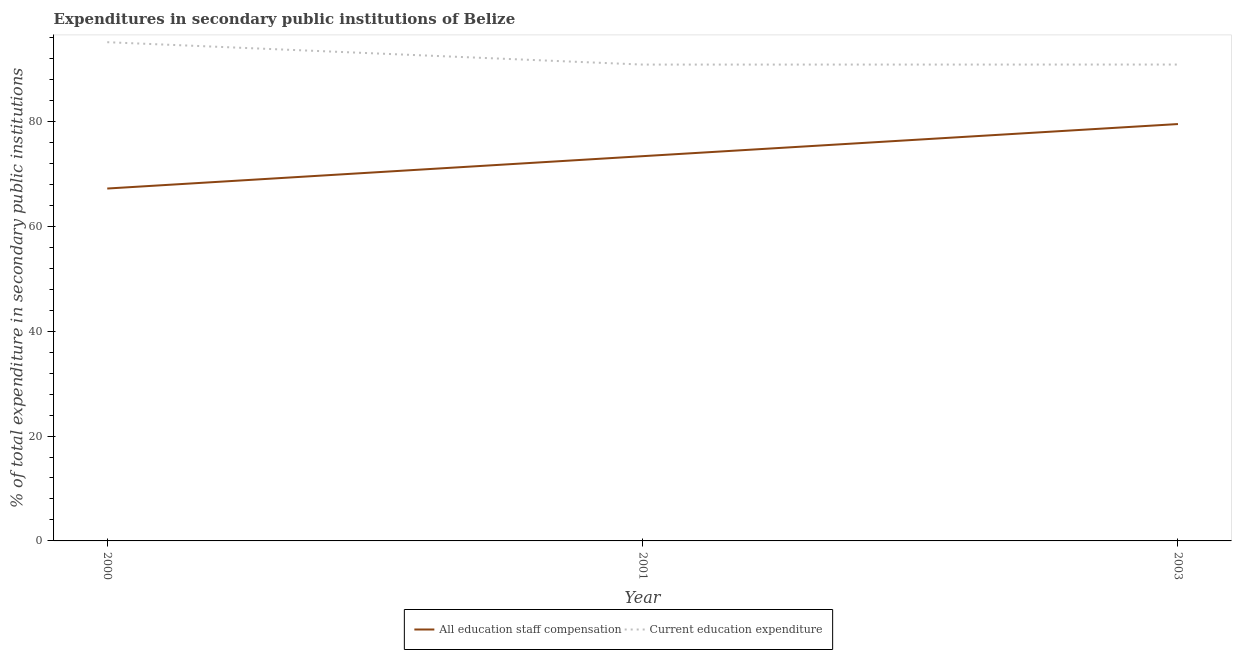Does the line corresponding to expenditure in education intersect with the line corresponding to expenditure in staff compensation?
Offer a very short reply. No. What is the expenditure in staff compensation in 2000?
Your answer should be very brief. 67.2. Across all years, what is the maximum expenditure in staff compensation?
Offer a very short reply. 79.49. Across all years, what is the minimum expenditure in staff compensation?
Ensure brevity in your answer.  67.2. In which year was the expenditure in education maximum?
Offer a terse response. 2000. What is the total expenditure in staff compensation in the graph?
Ensure brevity in your answer.  220.06. What is the difference between the expenditure in education in 2001 and that in 2003?
Your answer should be very brief. -0.01. What is the difference between the expenditure in staff compensation in 2000 and the expenditure in education in 2001?
Provide a short and direct response. -23.64. What is the average expenditure in education per year?
Give a very brief answer. 92.26. In the year 2001, what is the difference between the expenditure in education and expenditure in staff compensation?
Provide a succinct answer. 17.47. In how many years, is the expenditure in staff compensation greater than 40 %?
Your answer should be very brief. 3. What is the ratio of the expenditure in staff compensation in 2000 to that in 2003?
Offer a terse response. 0.85. Is the expenditure in staff compensation in 2000 less than that in 2003?
Your response must be concise. Yes. Is the difference between the expenditure in staff compensation in 2000 and 2003 greater than the difference between the expenditure in education in 2000 and 2003?
Give a very brief answer. No. What is the difference between the highest and the second highest expenditure in staff compensation?
Ensure brevity in your answer.  6.13. What is the difference between the highest and the lowest expenditure in staff compensation?
Provide a short and direct response. 12.3. Is the sum of the expenditure in education in 2000 and 2003 greater than the maximum expenditure in staff compensation across all years?
Your answer should be compact. Yes. Does the expenditure in education monotonically increase over the years?
Your answer should be compact. No. How many lines are there?
Provide a succinct answer. 2. Does the graph contain grids?
Keep it short and to the point. No. How are the legend labels stacked?
Your response must be concise. Horizontal. What is the title of the graph?
Keep it short and to the point. Expenditures in secondary public institutions of Belize. What is the label or title of the Y-axis?
Provide a succinct answer. % of total expenditure in secondary public institutions. What is the % of total expenditure in secondary public institutions in All education staff compensation in 2000?
Give a very brief answer. 67.2. What is the % of total expenditure in secondary public institutions of Current education expenditure in 2000?
Your response must be concise. 95.1. What is the % of total expenditure in secondary public institutions in All education staff compensation in 2001?
Provide a succinct answer. 73.37. What is the % of total expenditure in secondary public institutions in Current education expenditure in 2001?
Make the answer very short. 90.84. What is the % of total expenditure in secondary public institutions in All education staff compensation in 2003?
Your answer should be compact. 79.49. What is the % of total expenditure in secondary public institutions of Current education expenditure in 2003?
Your answer should be compact. 90.84. Across all years, what is the maximum % of total expenditure in secondary public institutions in All education staff compensation?
Your response must be concise. 79.49. Across all years, what is the maximum % of total expenditure in secondary public institutions of Current education expenditure?
Your response must be concise. 95.1. Across all years, what is the minimum % of total expenditure in secondary public institutions in All education staff compensation?
Your answer should be very brief. 67.2. Across all years, what is the minimum % of total expenditure in secondary public institutions in Current education expenditure?
Give a very brief answer. 90.84. What is the total % of total expenditure in secondary public institutions of All education staff compensation in the graph?
Offer a very short reply. 220.06. What is the total % of total expenditure in secondary public institutions in Current education expenditure in the graph?
Offer a terse response. 276.78. What is the difference between the % of total expenditure in secondary public institutions of All education staff compensation in 2000 and that in 2001?
Keep it short and to the point. -6.17. What is the difference between the % of total expenditure in secondary public institutions in Current education expenditure in 2000 and that in 2001?
Your answer should be compact. 4.27. What is the difference between the % of total expenditure in secondary public institutions in All education staff compensation in 2000 and that in 2003?
Your response must be concise. -12.3. What is the difference between the % of total expenditure in secondary public institutions in Current education expenditure in 2000 and that in 2003?
Your response must be concise. 4.26. What is the difference between the % of total expenditure in secondary public institutions in All education staff compensation in 2001 and that in 2003?
Make the answer very short. -6.13. What is the difference between the % of total expenditure in secondary public institutions in Current education expenditure in 2001 and that in 2003?
Your answer should be compact. -0.01. What is the difference between the % of total expenditure in secondary public institutions of All education staff compensation in 2000 and the % of total expenditure in secondary public institutions of Current education expenditure in 2001?
Your response must be concise. -23.64. What is the difference between the % of total expenditure in secondary public institutions in All education staff compensation in 2000 and the % of total expenditure in secondary public institutions in Current education expenditure in 2003?
Keep it short and to the point. -23.64. What is the difference between the % of total expenditure in secondary public institutions of All education staff compensation in 2001 and the % of total expenditure in secondary public institutions of Current education expenditure in 2003?
Ensure brevity in your answer.  -17.47. What is the average % of total expenditure in secondary public institutions of All education staff compensation per year?
Make the answer very short. 73.35. What is the average % of total expenditure in secondary public institutions in Current education expenditure per year?
Your response must be concise. 92.26. In the year 2000, what is the difference between the % of total expenditure in secondary public institutions of All education staff compensation and % of total expenditure in secondary public institutions of Current education expenditure?
Your answer should be compact. -27.91. In the year 2001, what is the difference between the % of total expenditure in secondary public institutions of All education staff compensation and % of total expenditure in secondary public institutions of Current education expenditure?
Make the answer very short. -17.47. In the year 2003, what is the difference between the % of total expenditure in secondary public institutions of All education staff compensation and % of total expenditure in secondary public institutions of Current education expenditure?
Make the answer very short. -11.35. What is the ratio of the % of total expenditure in secondary public institutions of All education staff compensation in 2000 to that in 2001?
Make the answer very short. 0.92. What is the ratio of the % of total expenditure in secondary public institutions of Current education expenditure in 2000 to that in 2001?
Give a very brief answer. 1.05. What is the ratio of the % of total expenditure in secondary public institutions of All education staff compensation in 2000 to that in 2003?
Offer a very short reply. 0.85. What is the ratio of the % of total expenditure in secondary public institutions in Current education expenditure in 2000 to that in 2003?
Your answer should be very brief. 1.05. What is the ratio of the % of total expenditure in secondary public institutions in All education staff compensation in 2001 to that in 2003?
Your answer should be very brief. 0.92. What is the difference between the highest and the second highest % of total expenditure in secondary public institutions in All education staff compensation?
Give a very brief answer. 6.13. What is the difference between the highest and the second highest % of total expenditure in secondary public institutions of Current education expenditure?
Ensure brevity in your answer.  4.26. What is the difference between the highest and the lowest % of total expenditure in secondary public institutions in All education staff compensation?
Give a very brief answer. 12.3. What is the difference between the highest and the lowest % of total expenditure in secondary public institutions of Current education expenditure?
Offer a very short reply. 4.27. 